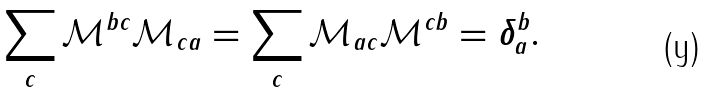<formula> <loc_0><loc_0><loc_500><loc_500>\sum _ { c } \mathcal { M } ^ { b c } \mathcal { M } _ { c a } = \sum _ { c } \mathcal { M } _ { a c } \mathcal { M } ^ { c b } = \delta ^ { b } _ { a } .</formula> 